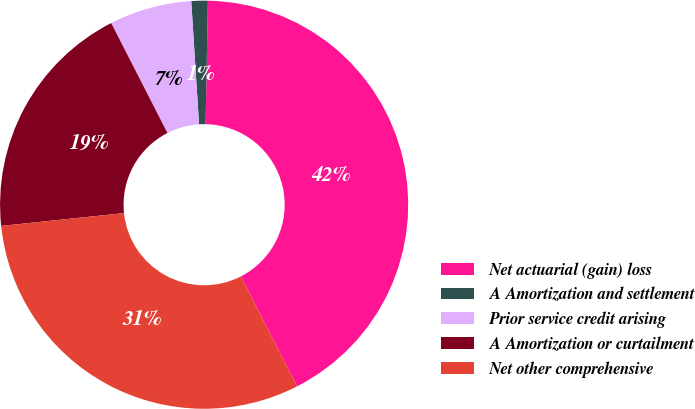Convert chart. <chart><loc_0><loc_0><loc_500><loc_500><pie_chart><fcel>Net actuarial (gain) loss<fcel>A Amortization and settlement<fcel>Prior service credit arising<fcel>A Amortization or curtailment<fcel>Net other comprehensive<nl><fcel>42.17%<fcel>1.3%<fcel>6.52%<fcel>19.13%<fcel>30.87%<nl></chart> 